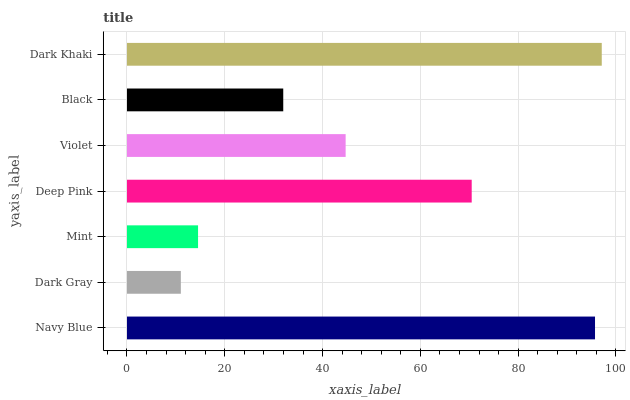Is Dark Gray the minimum?
Answer yes or no. Yes. Is Dark Khaki the maximum?
Answer yes or no. Yes. Is Mint the minimum?
Answer yes or no. No. Is Mint the maximum?
Answer yes or no. No. Is Mint greater than Dark Gray?
Answer yes or no. Yes. Is Dark Gray less than Mint?
Answer yes or no. Yes. Is Dark Gray greater than Mint?
Answer yes or no. No. Is Mint less than Dark Gray?
Answer yes or no. No. Is Violet the high median?
Answer yes or no. Yes. Is Violet the low median?
Answer yes or no. Yes. Is Deep Pink the high median?
Answer yes or no. No. Is Navy Blue the low median?
Answer yes or no. No. 